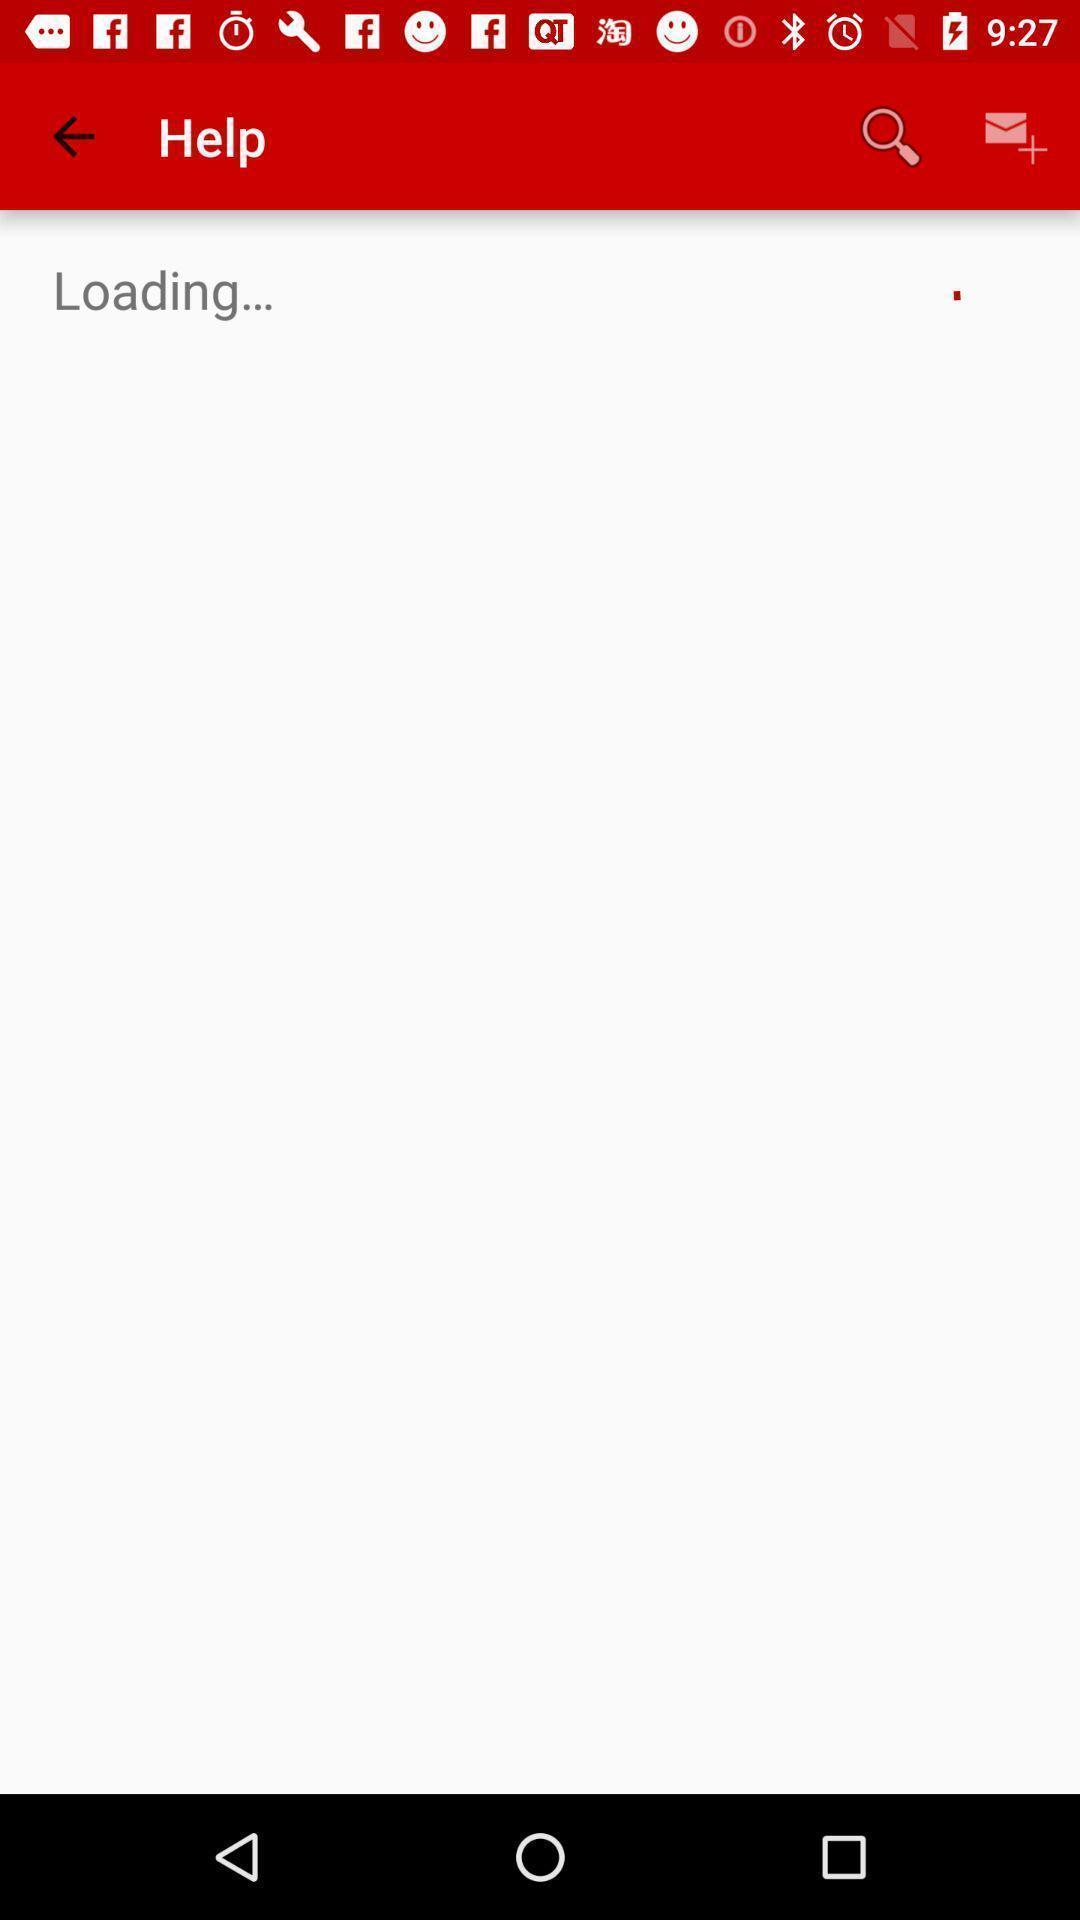Tell me about the visual elements in this screen capture. Window displaying health fitness page. 